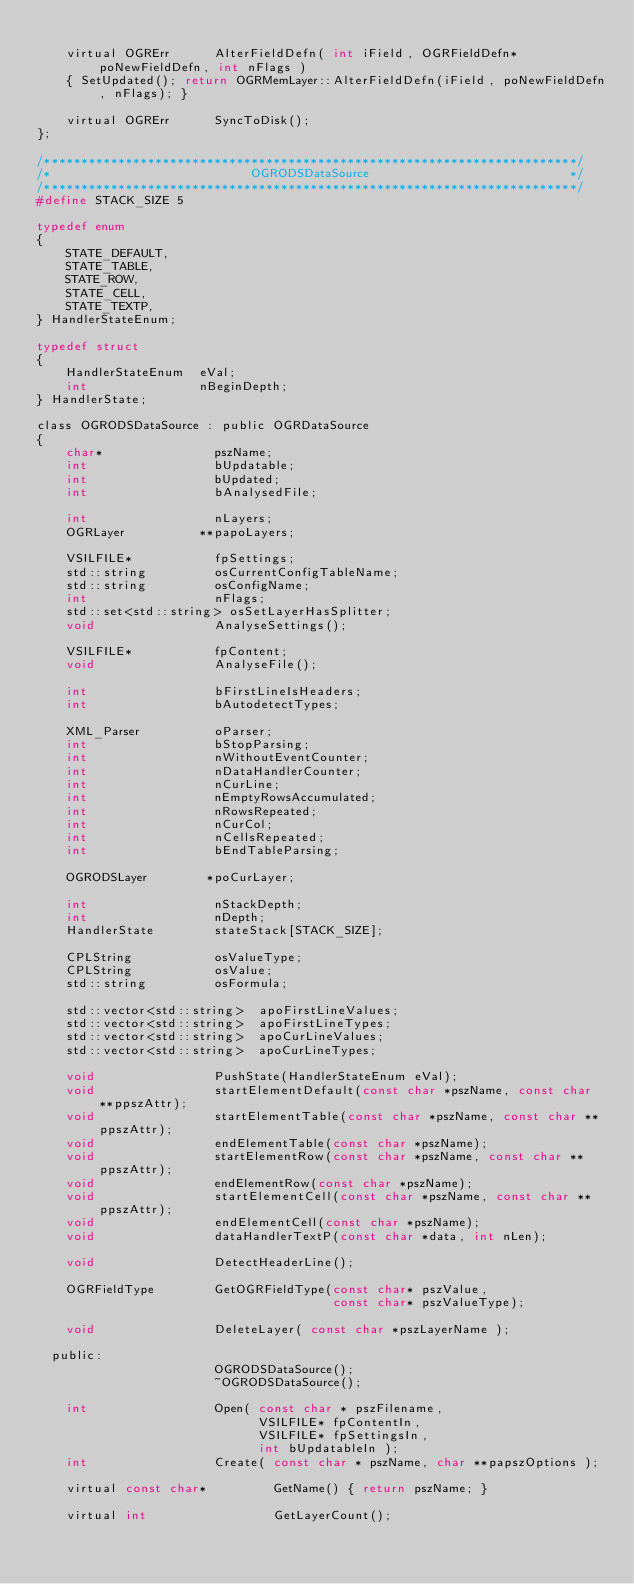<code> <loc_0><loc_0><loc_500><loc_500><_C_>
    virtual OGRErr      AlterFieldDefn( int iField, OGRFieldDefn* poNewFieldDefn, int nFlags )
    { SetUpdated(); return OGRMemLayer::AlterFieldDefn(iField, poNewFieldDefn, nFlags); }

    virtual OGRErr      SyncToDisk();
};

/************************************************************************/
/*                           OGRODSDataSource                           */
/************************************************************************/
#define STACK_SIZE 5

typedef enum
{
    STATE_DEFAULT,
    STATE_TABLE,
    STATE_ROW,
    STATE_CELL,
    STATE_TEXTP,
} HandlerStateEnum;

typedef struct
{
    HandlerStateEnum  eVal;
    int               nBeginDepth;
} HandlerState;

class OGRODSDataSource : public OGRDataSource
{
    char*               pszName;
    int                 bUpdatable;
    int                 bUpdated;
    int                 bAnalysedFile;

    int                 nLayers;
    OGRLayer          **papoLayers;

    VSILFILE*           fpSettings;
    std::string         osCurrentConfigTableName;
    std::string         osConfigName;
    int                 nFlags;
    std::set<std::string> osSetLayerHasSplitter;
    void                AnalyseSettings();

    VSILFILE*           fpContent;
    void                AnalyseFile();

    int                 bFirstLineIsHeaders;
    int                 bAutodetectTypes;

    XML_Parser          oParser;
    int                 bStopParsing;
    int                 nWithoutEventCounter;
    int                 nDataHandlerCounter;
    int                 nCurLine;
    int                 nEmptyRowsAccumulated;
    int                 nRowsRepeated;
    int                 nCurCol;
    int                 nCellsRepeated;
    int                 bEndTableParsing;

    OGRODSLayer        *poCurLayer;

    int                 nStackDepth;
    int                 nDepth;
    HandlerState        stateStack[STACK_SIZE];

    CPLString           osValueType;
    CPLString           osValue;
    std::string         osFormula;

    std::vector<std::string>  apoFirstLineValues;
    std::vector<std::string>  apoFirstLineTypes;
    std::vector<std::string>  apoCurLineValues;
    std::vector<std::string>  apoCurLineTypes;

    void                PushState(HandlerStateEnum eVal);
    void                startElementDefault(const char *pszName, const char **ppszAttr);
    void                startElementTable(const char *pszName, const char **ppszAttr);
    void                endElementTable(const char *pszName);
    void                startElementRow(const char *pszName, const char **ppszAttr);
    void                endElementRow(const char *pszName);
    void                startElementCell(const char *pszName, const char **ppszAttr);
    void                endElementCell(const char *pszName);
    void                dataHandlerTextP(const char *data, int nLen);

    void                DetectHeaderLine();

    OGRFieldType        GetOGRFieldType(const char* pszValue,
                                        const char* pszValueType);

    void                DeleteLayer( const char *pszLayerName );

  public:
                        OGRODSDataSource();
                        ~OGRODSDataSource();

    int                 Open( const char * pszFilename,
                              VSILFILE* fpContentIn,
                              VSILFILE* fpSettingsIn,
                              int bUpdatableIn );
    int                 Create( const char * pszName, char **papszOptions );

    virtual const char*         GetName() { return pszName; }

    virtual int                 GetLayerCount();</code> 